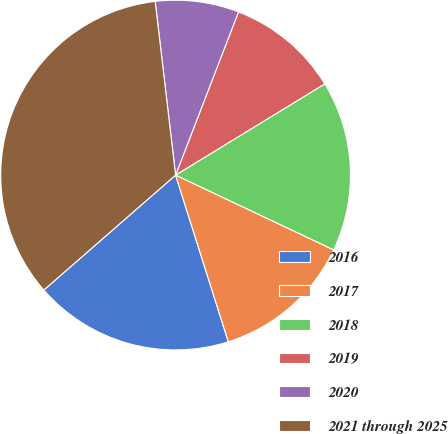<chart> <loc_0><loc_0><loc_500><loc_500><pie_chart><fcel>2016<fcel>2017<fcel>2018<fcel>2019<fcel>2020<fcel>2021 through 2025<nl><fcel>18.46%<fcel>13.09%<fcel>15.77%<fcel>10.41%<fcel>7.72%<fcel>34.56%<nl></chart> 